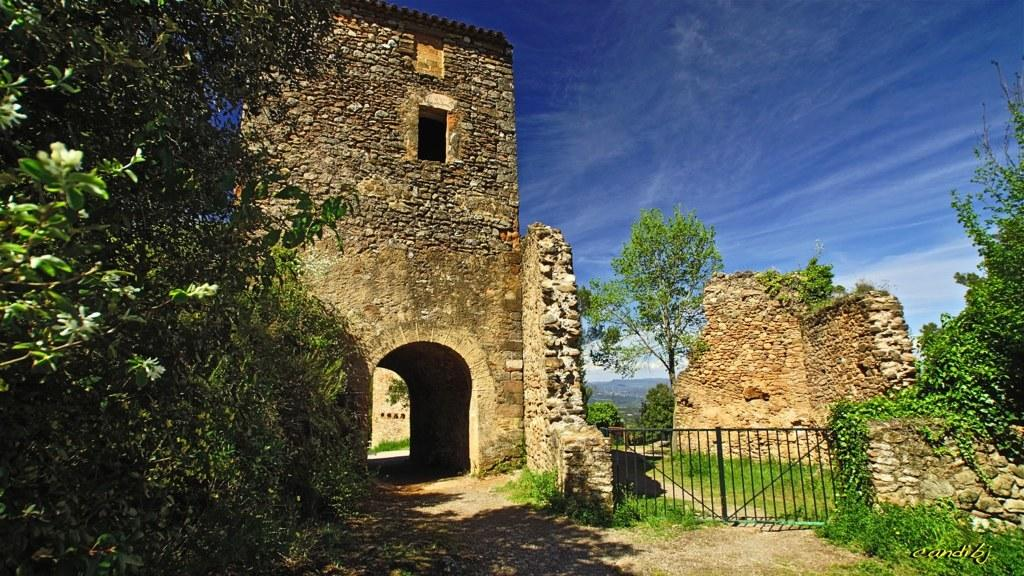What type of vegetation is on the left side of the image? There are trees on the left side of the image. What type of structure is visible in the image? There is an arch of a stone building in the image. What is located beside the stone building? There is a gate beside the stone building. Are there any other trees visible in the image? Yes, there are trees visible in the image. What type of material is used for the walls in the image? The walls in the image are made of stone. What is visible at the top of the image? The sky is visible at the top of the image. How many coils can be seen in the image? There are no coils present in the image. What type of leg is visible in the image? There are no legs visible in the image. 